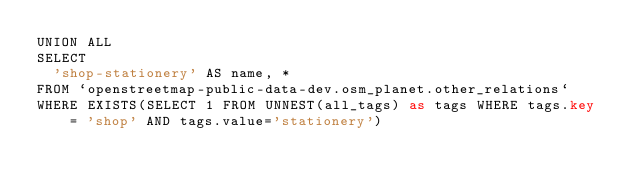<code> <loc_0><loc_0><loc_500><loc_500><_SQL_>UNION ALL
SELECT
  'shop-stationery' AS name, *
FROM `openstreetmap-public-data-dev.osm_planet.other_relations`
WHERE EXISTS(SELECT 1 FROM UNNEST(all_tags) as tags WHERE tags.key = 'shop' AND tags.value='stationery')

</code> 